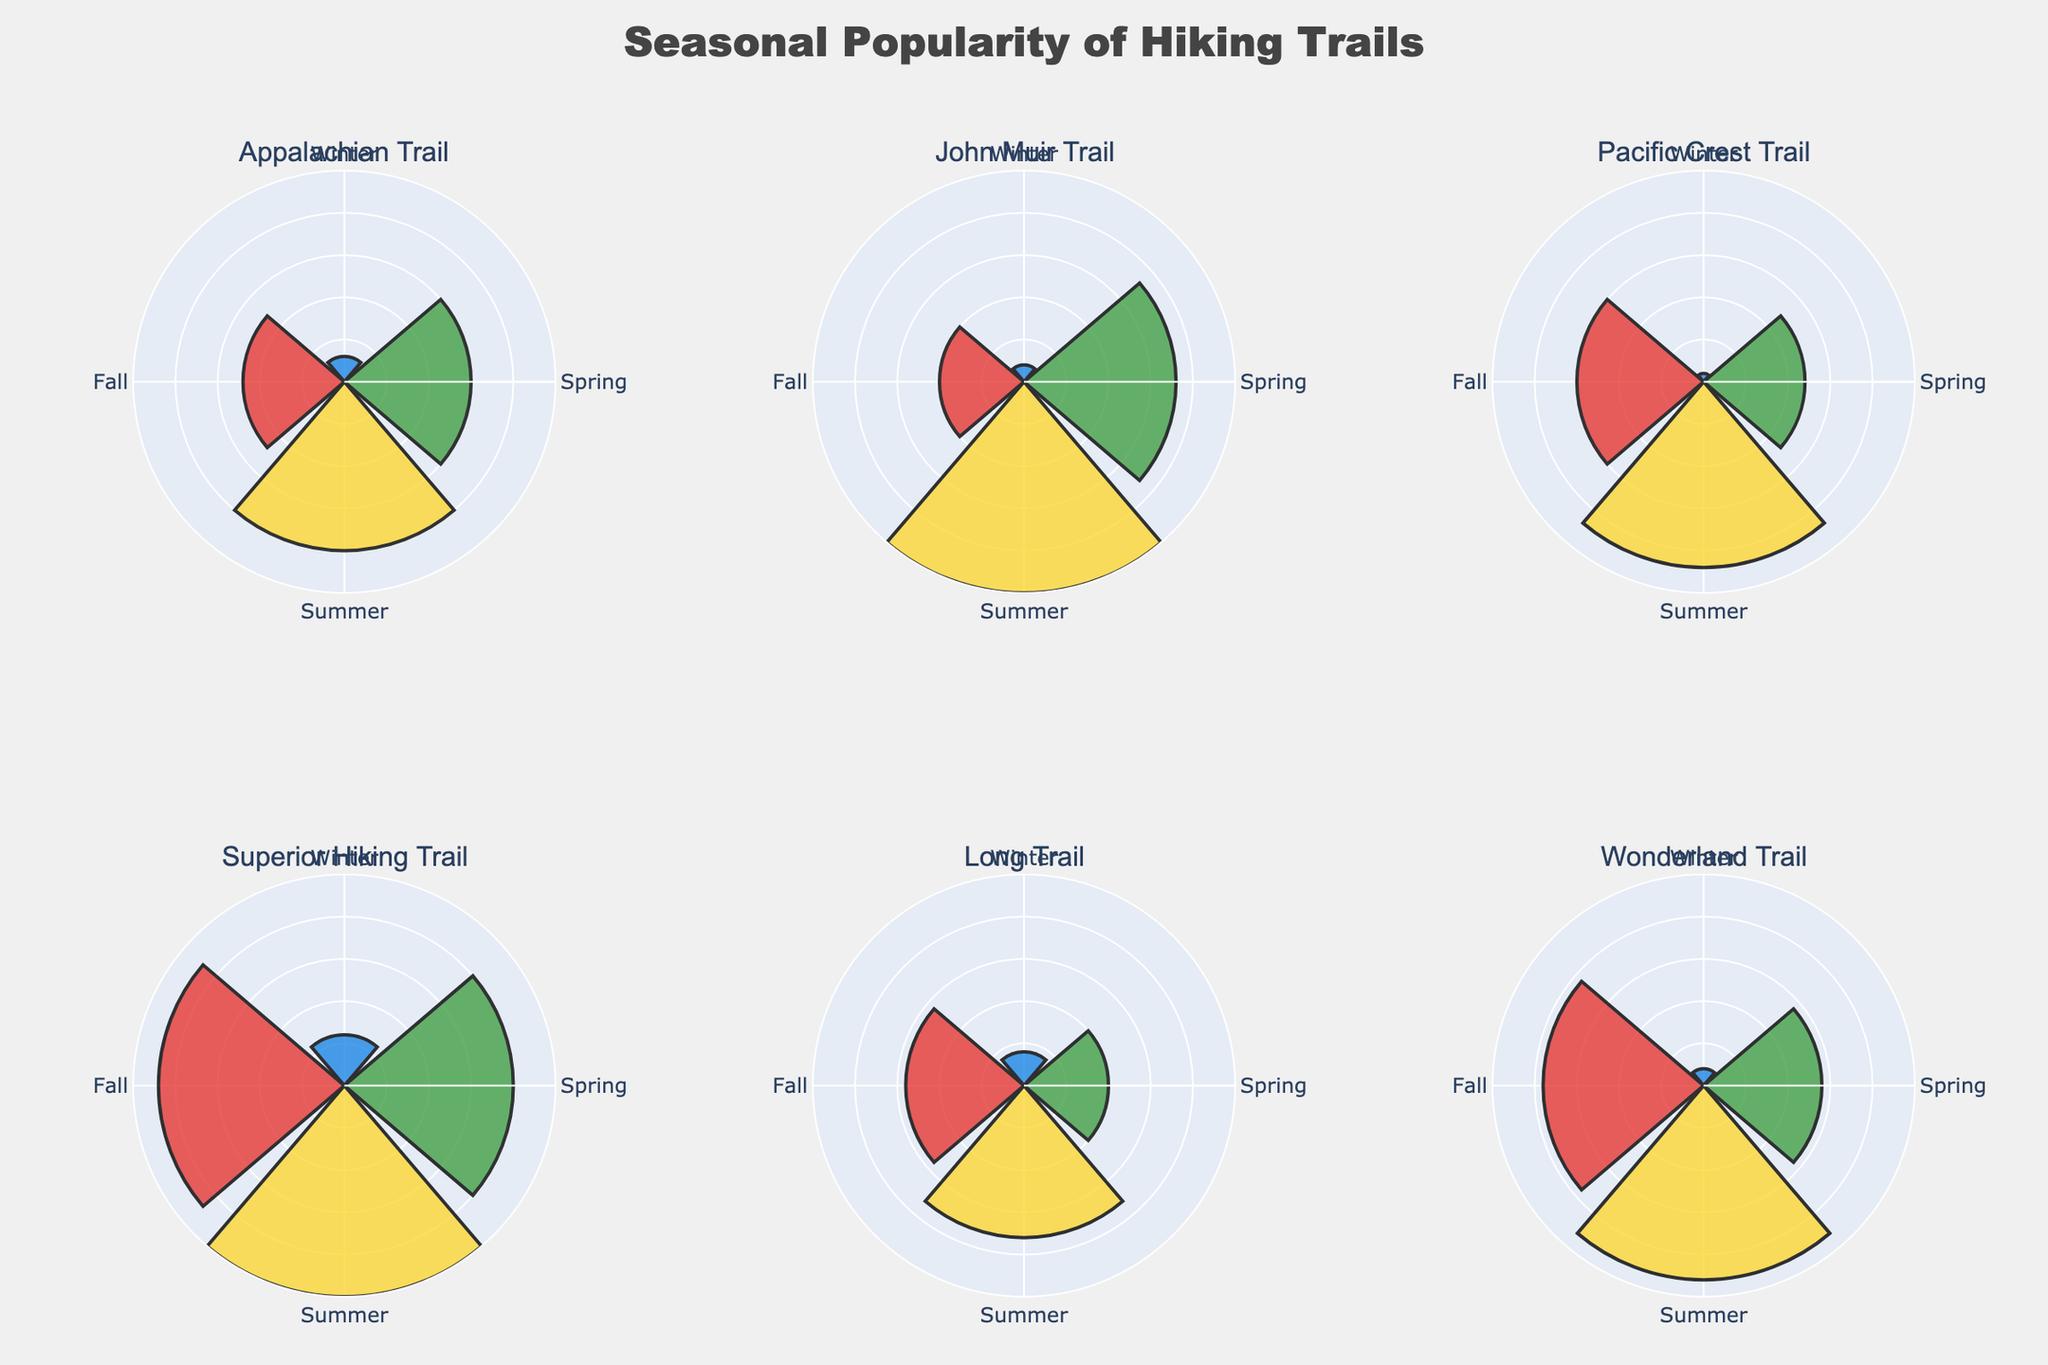What's the title of the figure? The figure's title is typically displayed prominently at the top. The title provides an overview of what the chart represents. In this case, it would mention the theme of the figure.
Answer: "Seasonal Popularity of Hiking Trails" Which trail has the highest popularity in summer? To find the trail with the highest popularity in summer, look at the summer section of each subplot (colored yellow). Find the one with the longest bar.
Answer: John Muir Trail Which trail is the least popular in winter? To determine the least popular trail in winter, check the winter section of each subplot (colored blue). The shortest bar indicates the least popular trail.
Answer: Pacific Crest Trail Compare the popularity of the Appalachian Trail in winter and fall. Which season is it more popular in? Examine the lengths of the bars for the Appalachian Trail in both the winter (blue) and fall (red) sections. Compare the two lengths to see which is longer.
Answer: Fall What is the combined popularity of the Superior Hiking Trail in spring and summer? Add the values for the Superior Hiking Trail in spring (green) and summer (yellow) sections. According to the data provided, these values are 20 and 25 respectively. Sum them up to get the combined value.
Answer: 45 Which trail shows the most consistent popularity across all seasons? Consistency can be measured by the variation in bar lengths across all seasons. The trail with the least variation (smallest range between the highest and lowest value) is the most consistent.
Answer: Long Trail How does the popularity of the Wonderland Trail in fall compare to its popularity in winter? Look at the lengths of the bars for the Wonderland Trail in both fall (red) and winter (blue). Compare these two bars to determine the relationship between these values.
Answer: Fall is more popular Which trail is more popular in spring, the Appalachian Trail or the Long Trail? Compare the lengths of the bars for the Appalachian Trail and the Long Trail in the spring section (green). The longer bar indicates the more popular trail in that season.
Answer: Appalachian Trail What is the average popularity of the Pacific Crest Trail across all seasons? Find the values of the Pacific Crest Trail for winter (1), spring (12), summer (22), and fall (15). Sum these values and divide by the number of seasons (4) to get the average. \( (1 + 12 + 22 + 15) / 4 = 12.5 \)
Answer: 12.5 How many trails have their highest popularity in summer? Count the number of subplots where the yellow bar (summer) is the longest out of the four seasonal bars. This can help identify which trails peak in summer.
Answer: 5 